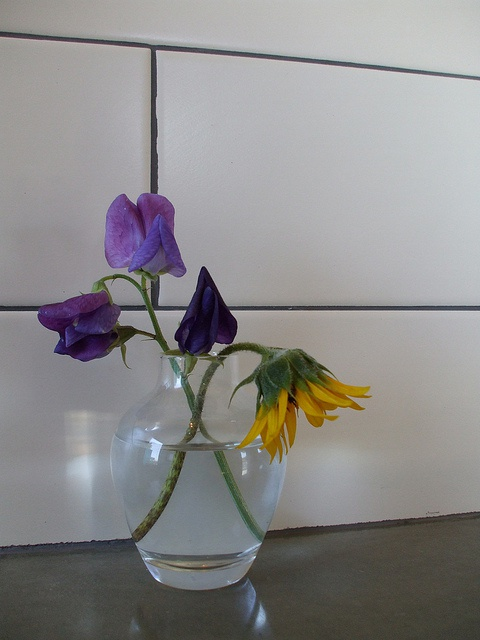Describe the objects in this image and their specific colors. I can see potted plant in gray and black tones and vase in gray tones in this image. 